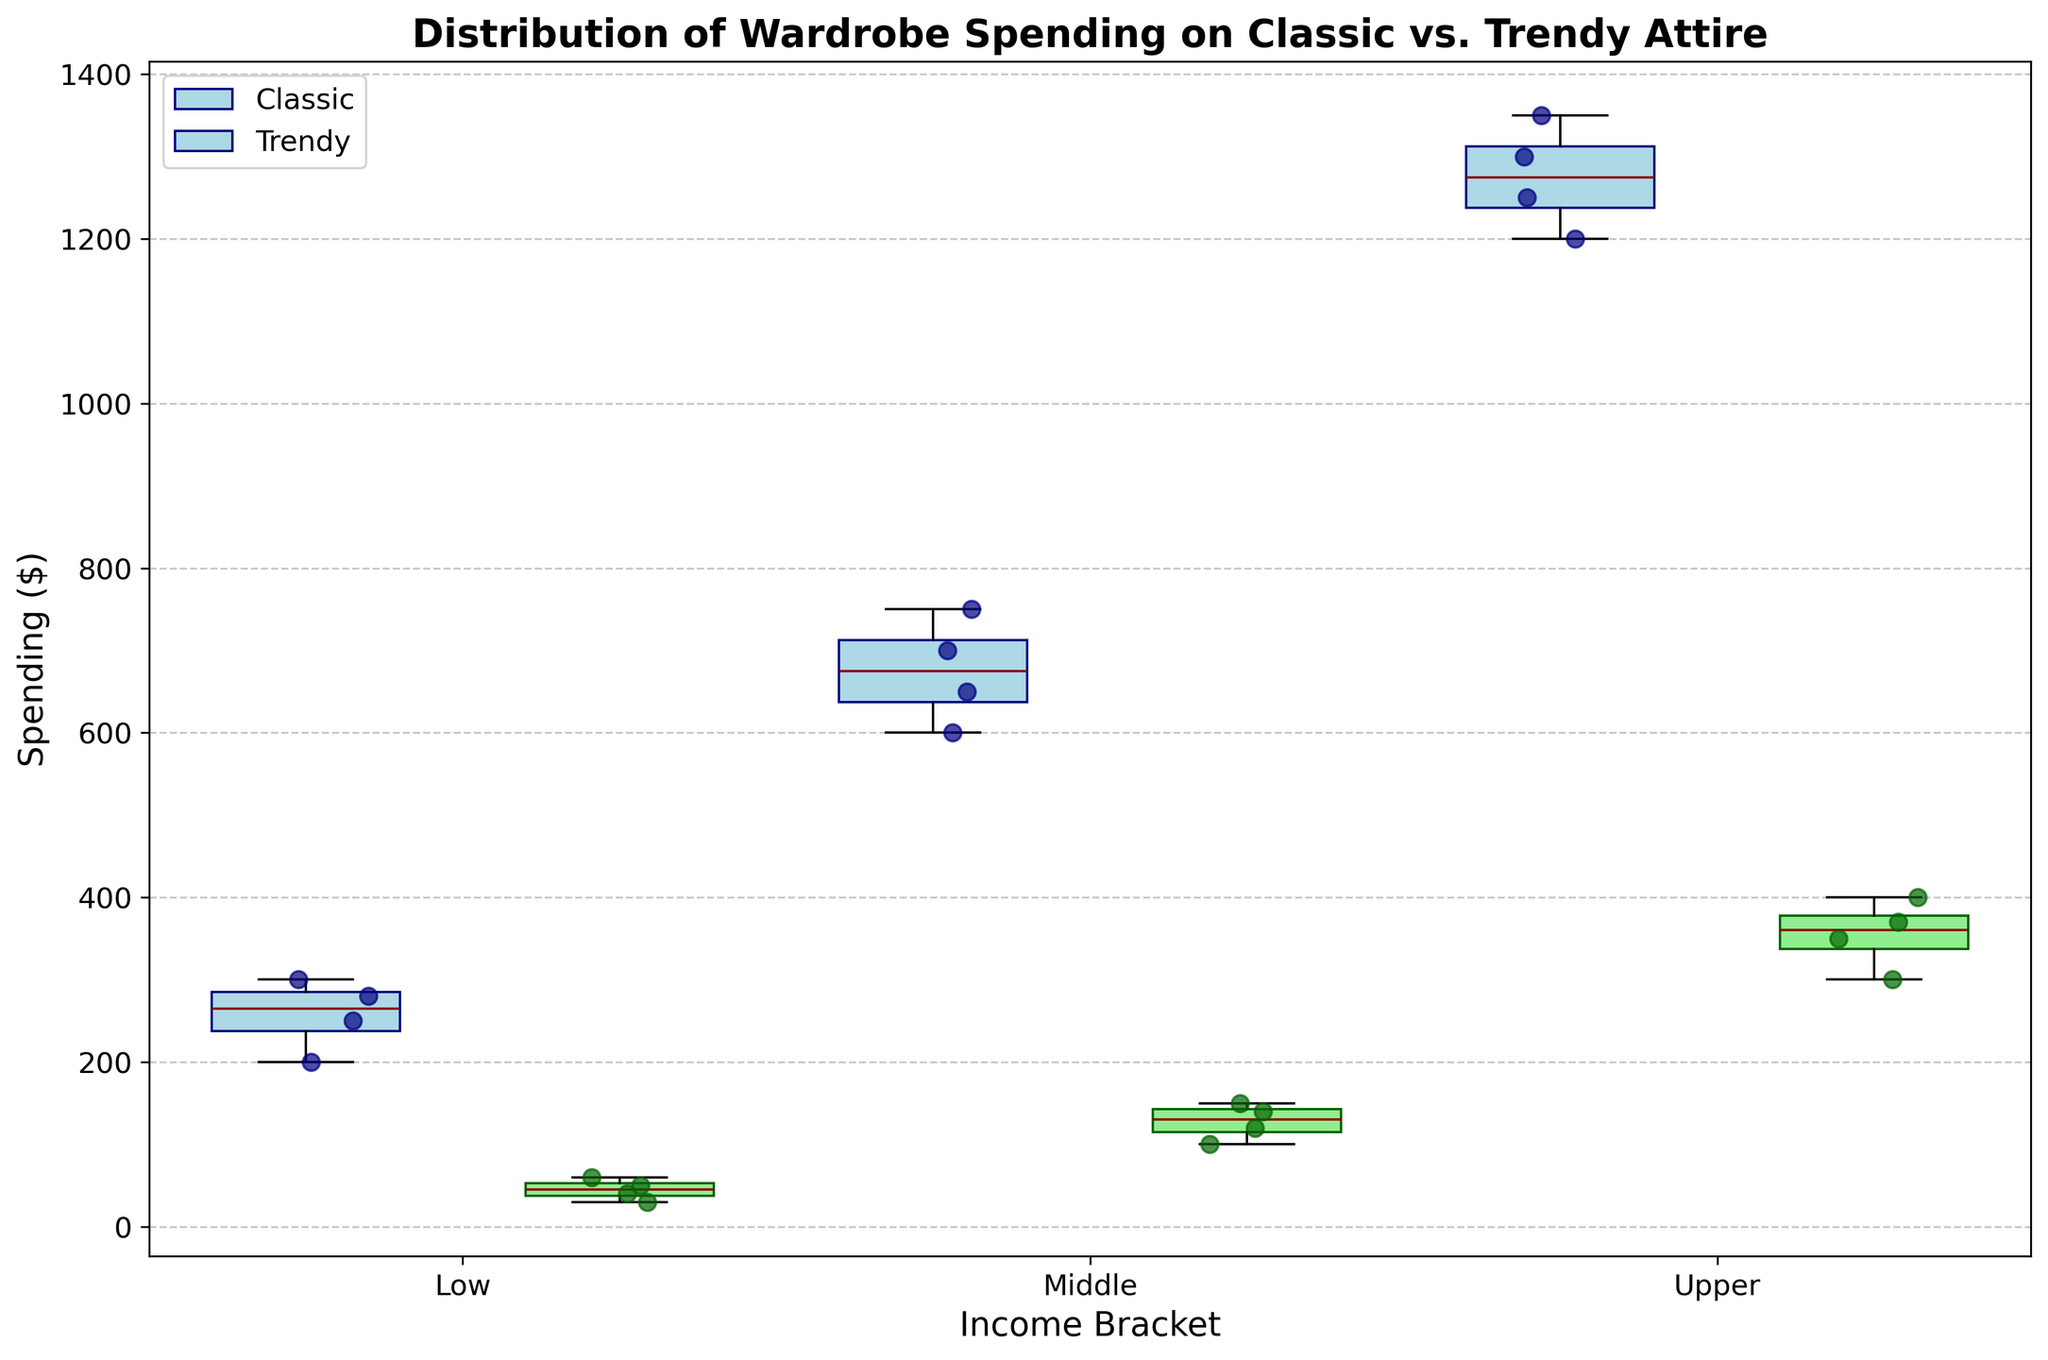What's the title of the plot? The title of the plot is located at the top and usually in a larger, bold font. By looking at the top centered text, we can read the title as it is shared to give an overview of the data being visualized.
Answer: Distribution of Wardrobe Spending on Classic vs. Trendy Attire What are the different income brackets shown on the x-axis? The x-axis labels denote the categories in the data. By looking at the positions along the x-axis, we can see that there are three income brackets labeled 'Low', 'Middle', and 'Upper'.
Answer: Low, Middle, Upper How is the spending on classic attire different from trendy attire in the middle income bracket? By examining the box plots and scatter points for the middle income bracket: position 3 (classic) and position 4 (trendy), we observe the height and spread of the boxes as well as the median lines. The spending on classic attire (position 3) shows higher values and a wider range compared to trendy attire (position 4).
Answer: Spending on classic attire is higher What is the median spending on trendy attire for the upper income bracket? The median spending is indicated by the dark red line within the box plot. For trendy attire in the upper income bracket (position 6), we look for this line within the box. The dark red line represents the monetary value at the median.
Answer: 370 Which income bracket spends the least on trendy attire? To determine this, we compare the height of the lower end of the boxes for trendy attire (positions 2, 4, and 6) across all income brackets. The bracket with the lowest box indicates the least spending. The low-income bracket (position 2) shows the lowest spending on trendy attire.
Answer: Low Are there any outliers in spending on classic attire among the upper income bracket? Outliers are usually indicated by individual scatter points that lie outside the range of the whiskers of the box plot. For the upper income bracket (position 5, classic attire), we look for any points beyond the end of the whiskers. There are no scattered points beyond the whisker ends, indicating no outliers.
Answer: No What is the predominant spending range for classic attire in the low-income bracket? To find the range, observe the box plot for the low-income bracket classic attire (position 1). The bottom of the box represents the 25th percentile, and the top of the box represents the 75th percentile. The interquartile range (IQR) is from 200 to 280 USD.
Answer: 200-280 How do the ranges of spending on trendy attire compare between middle and upper income brackets? To compare, examine the length of the boxes for trendy attire in the middle (position 4) and upper (position 6) income brackets. Evaluate the difference between the top and bottom of the boxes (interquartile range). The middle-income bracket has a range of ~100 to ~150 USD, while the upper-income bracket has a range of ~370 to ~400 USD.
Answer: Upper income has a higher range Is there a significant difference in the top 25% spending on classic attire between middle and upper income brackets? To assess this, we compare the third quartile (top of the box) for classic attire in the middle-income bracket (position 3) and upper-income bracket (position 5). The third quartile for middle income is ~700 USD, while for upper income, it is ~1350 USD. The upper income's top 25% spending is significantly higher.
Answer: Yes Do scatter points show greater variability in trendy attire spending for low income compared to classic attire? Scatter points indicate individual data points' spread around the mean. By comparing low income scatter points at positions 1 and 2, we can see the extent of variability. The trendy attire scatter points (position 2) are more spread out compared to classic attire (position 1), indicating higher variability.
Answer: Yes 